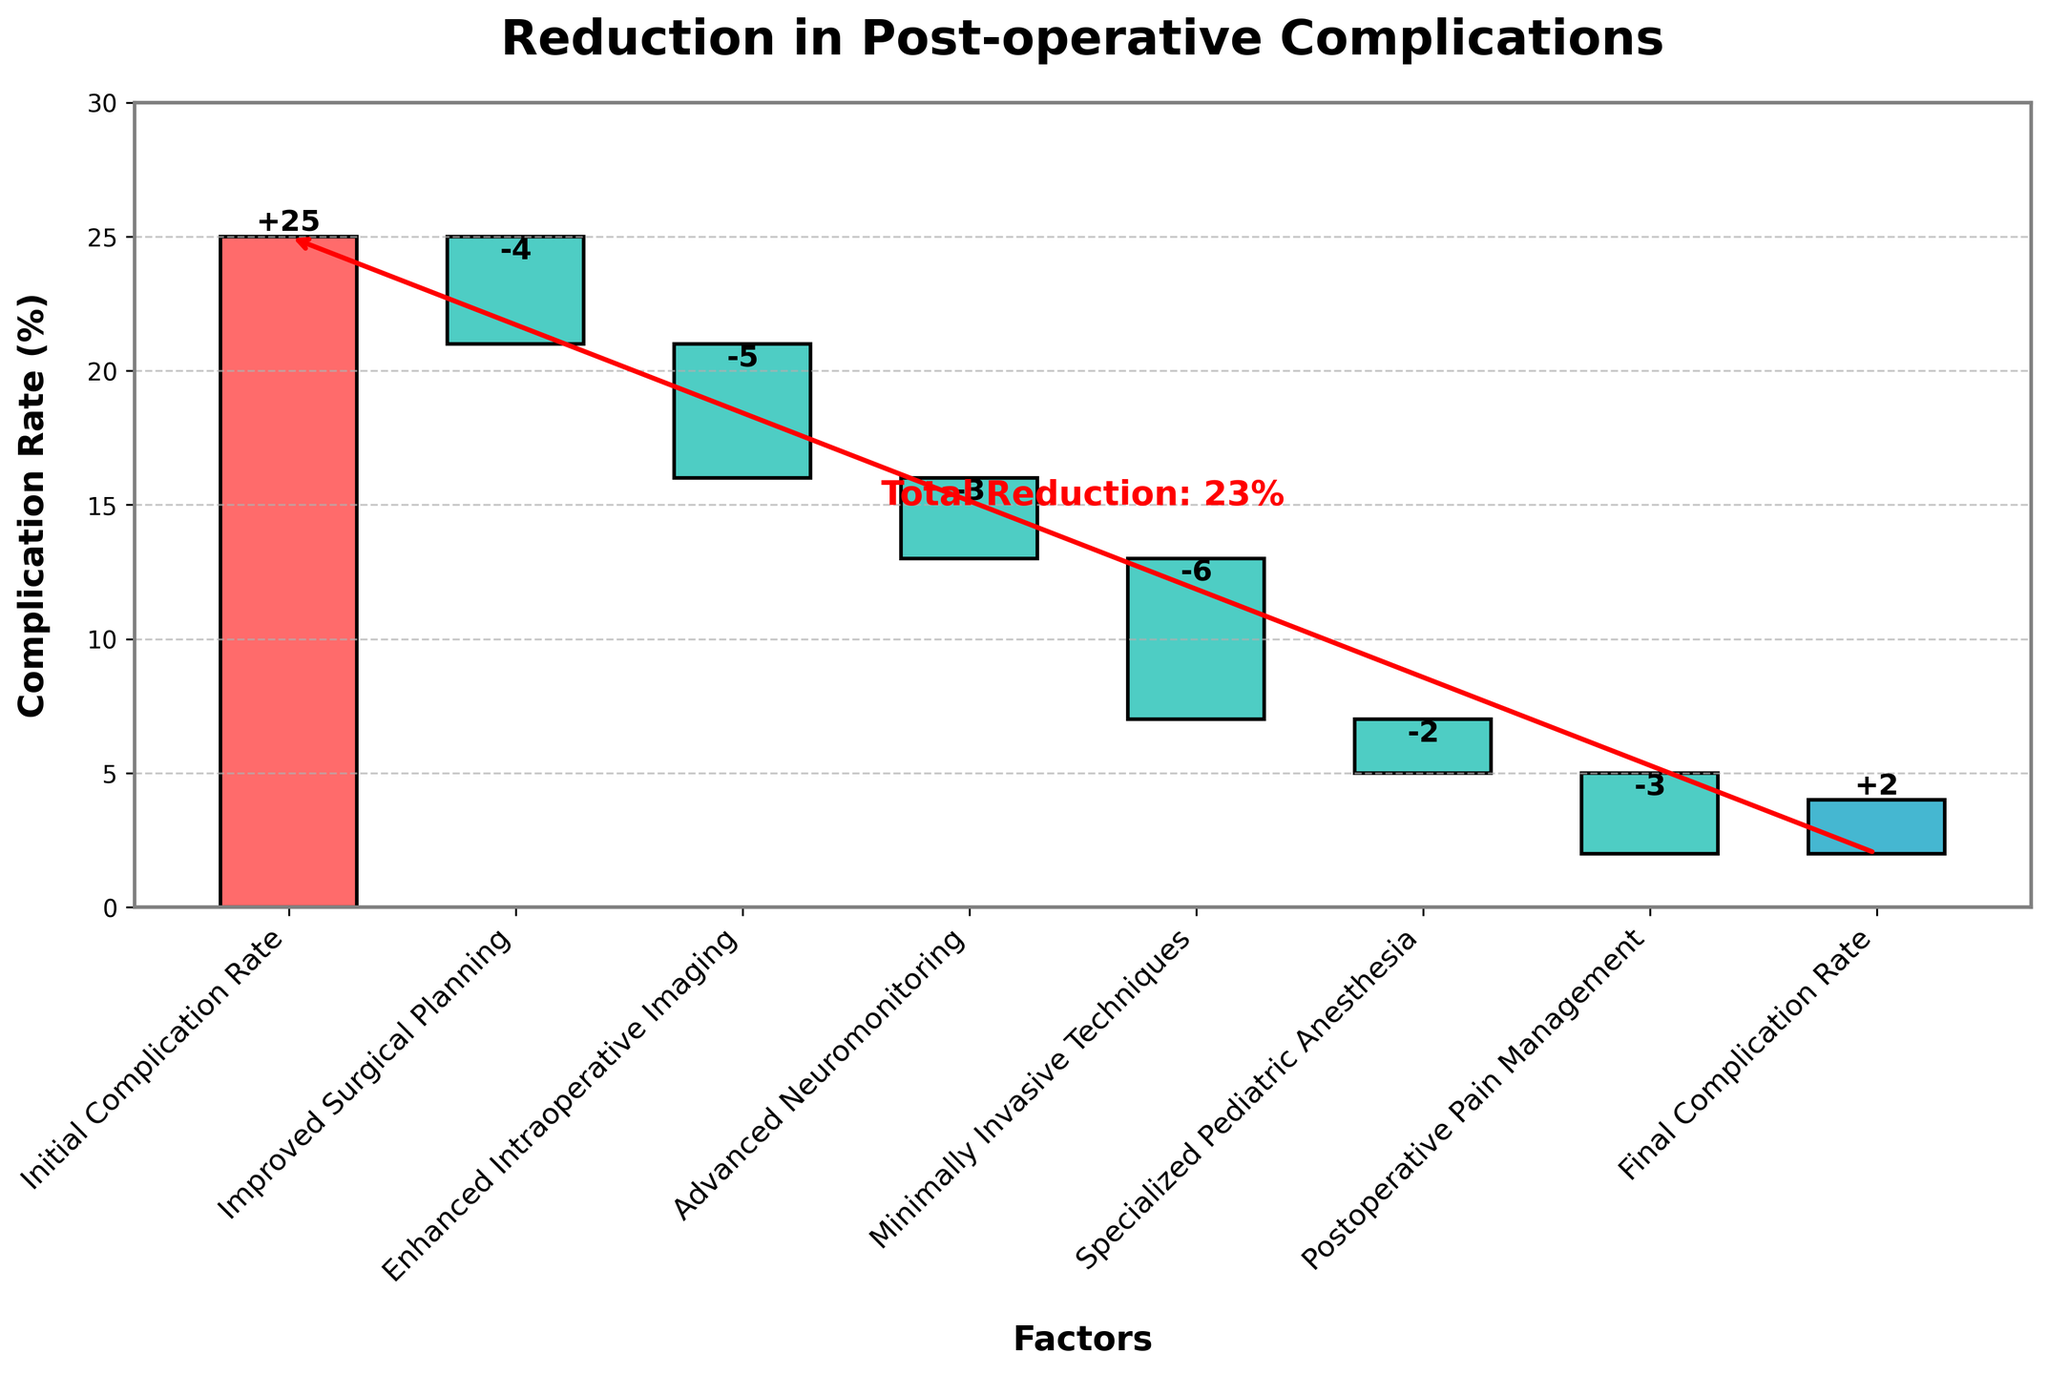What is the title of the chart? The title of the chart is usually placed at the top of the plot. In this case, it reads "Reduction in Post-operative Complications."
Answer: Reduction in Post-operative Complications What is the initial complication rate? The initial complication rate is the starting value on the chart, labeled as "Initial Complication Rate." It is the first bar in the Waterfall Chart.
Answer: 25% What is the final complication rate? The final complication rate is the value at the end of the Waterfall Chart, labeled "Final Complication Rate." It is the last bar in the chart.
Answer: 2% How much did Improved Surgical Planning reduce the complication rate? To find the reduction amount from Improved Surgical Planning, refer to the bar labeled "Improved Surgical Planning." The value is indicated as a negative amount.
Answer: -4% Which factor contributed the most to reducing the complication rate? Examine the bars in the chart and look for the factor with the most significant negative value. The longest downward bar indicates the greatest reduction.
Answer: Minimally Invasive Techniques What is the total reduction in complication rate from all factors combined? Start with the initial complication rate and subtract the cumulative reductions of all factors: 25 - 4 - 5 - 3 - 6 - 2 - 3. This leaves the final complication rate of 2%.
Answer: 23% Which factor had the smallest impact on reducing the complication rate? Look for the factor with the smallest negative value. This factor will correspond to the shortest downward bar in the chart.
Answer: Specialized Pediatric Anesthesia What cumulative complication rate is reached after implementing Enhanced Intraoperative Imaging? Start with the initial complication rate (25%) and subtract the reductions from both Improved Surgical Planning and Enhanced Intraoperative Imaging (-4 and -5 respectively): 25 - 4 - 5.
Answer: 16% By what percentage did Minimally Invasive Techniques reduce the initial complication rate? The initial complication rate is 25%. Minimally Invasive Techniques reduced the rate by 6%. Calculate the percentage reduction: (6/25) * 100%.
Answer: 24% How does the reduction contribution of Postoperative Pain Management compare to Advanced Neuromonitoring? Compare the absolute values of the reductions for both factors: Postoperative Pain Management (-3%) and Advanced Neuromonitoring (-3%). Both factors contribute equally to the reduction.
Answer: Equal 